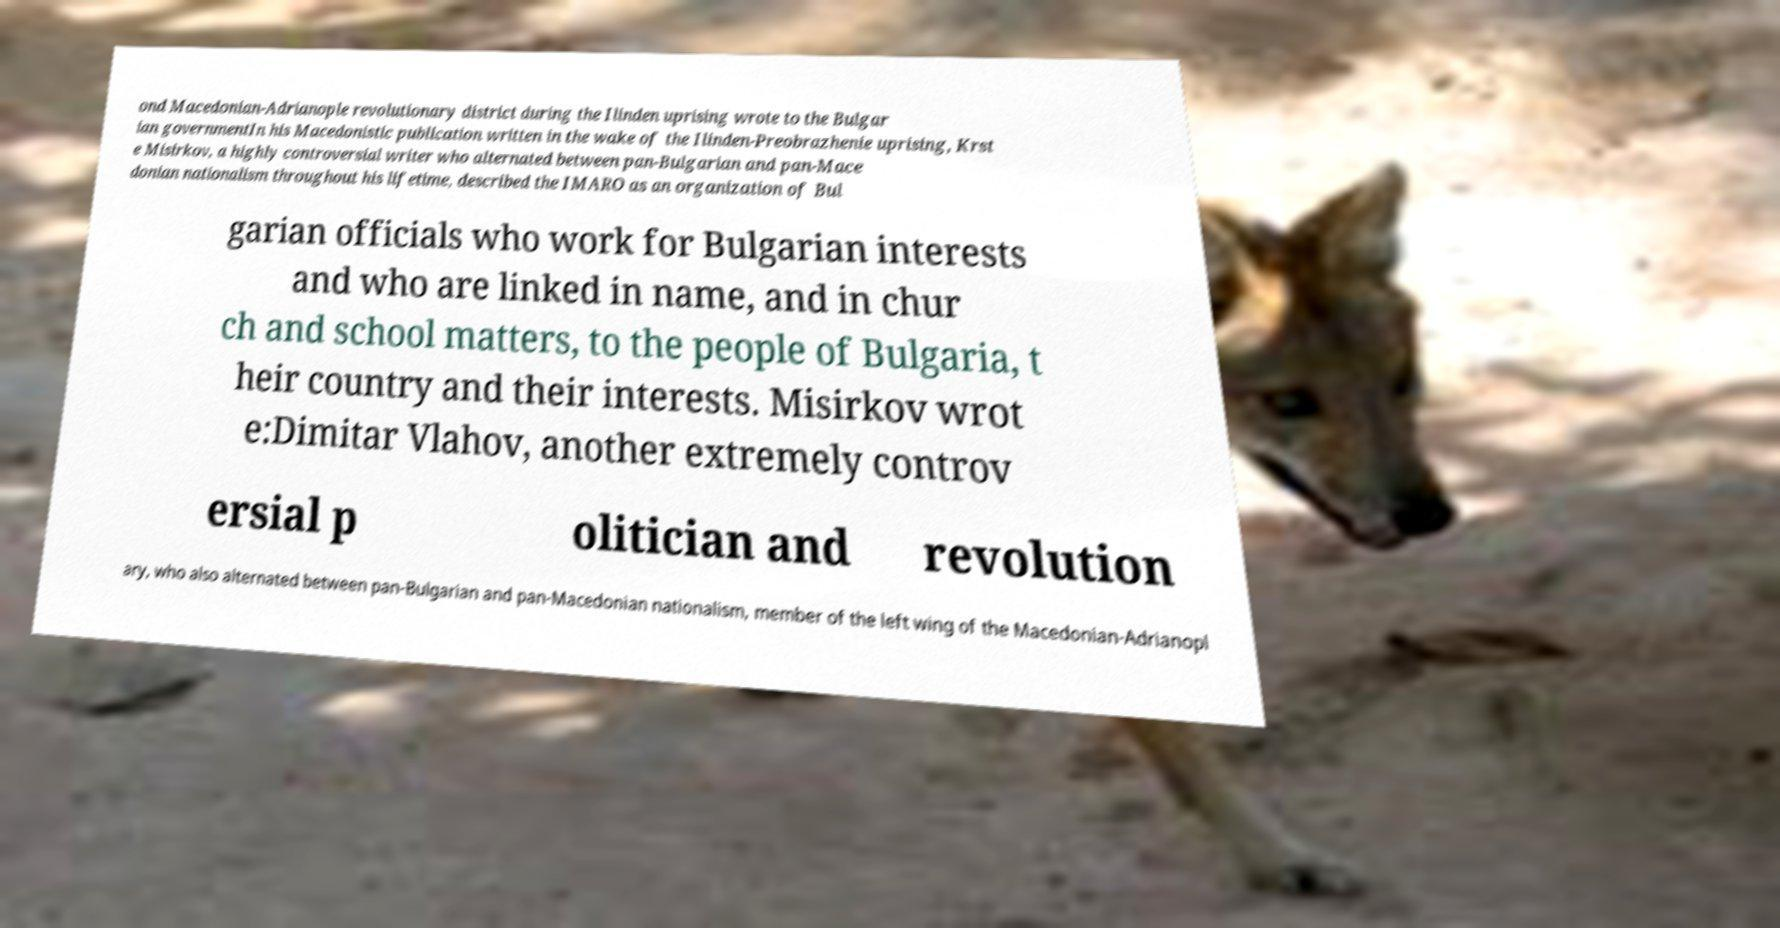There's text embedded in this image that I need extracted. Can you transcribe it verbatim? ond Macedonian-Adrianople revolutionary district during the Ilinden uprising wrote to the Bulgar ian governmentIn his Macedonistic publication written in the wake of the Ilinden-Preobrazhenie uprising, Krst e Misirkov, a highly controversial writer who alternated between pan-Bulgarian and pan-Mace donian nationalism throughout his lifetime, described the IMARO as an organization of Bul garian officials who work for Bulgarian interests and who are linked in name, and in chur ch and school matters, to the people of Bulgaria, t heir country and their interests. Misirkov wrot e:Dimitar Vlahov, another extremely controv ersial p olitician and revolution ary, who also alternated between pan-Bulgarian and pan-Macedonian nationalism, member of the left wing of the Macedonian-Adrianopl 